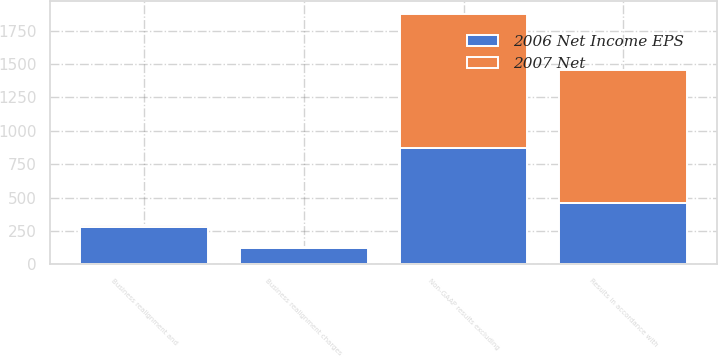Convert chart to OTSL. <chart><loc_0><loc_0><loc_500><loc_500><stacked_bar_chart><ecel><fcel>Results in accordance with<fcel>Business realignment charges<fcel>Business realignment and<fcel>Non-GAAP results excluding<nl><fcel>2006 Net Income EPS<fcel>458.8<fcel>123.1<fcel>276.9<fcel>871.4<nl><fcel>2007 Net<fcel>992.6<fcel>3.2<fcel>14.5<fcel>1004.2<nl></chart> 